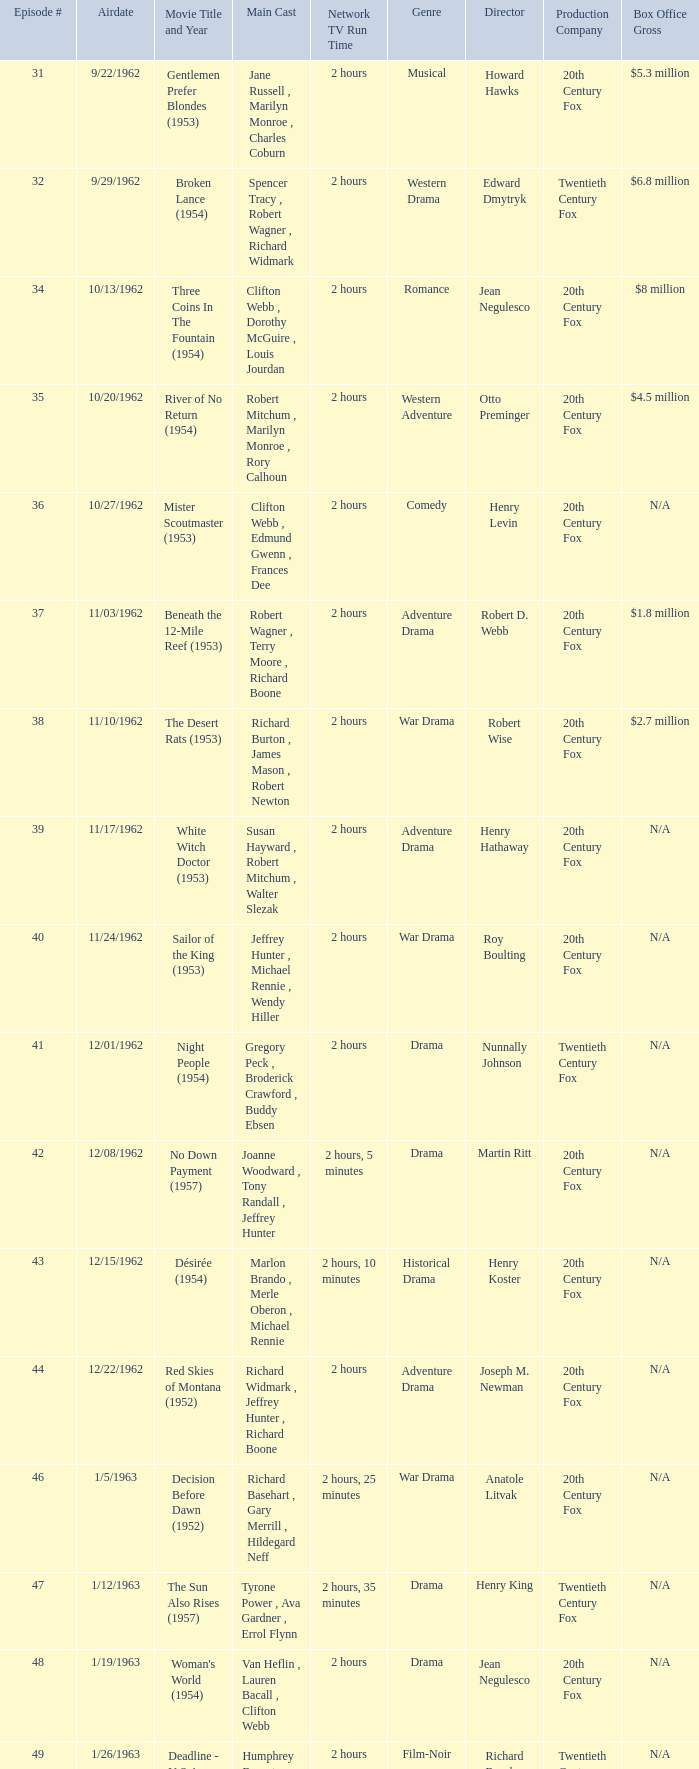How many runtimes does episode 53 have? 1.0. 